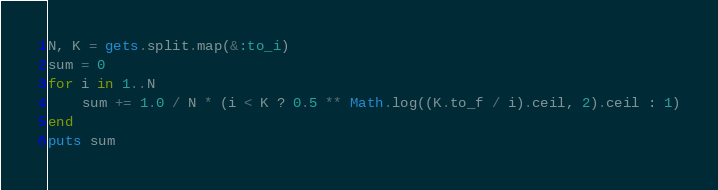<code> <loc_0><loc_0><loc_500><loc_500><_Ruby_>N, K = gets.split.map(&:to_i)
sum = 0
for i in 1..N
    sum += 1.0 / N * (i < K ? 0.5 ** Math.log((K.to_f / i).ceil, 2).ceil : 1)
end
puts sum</code> 